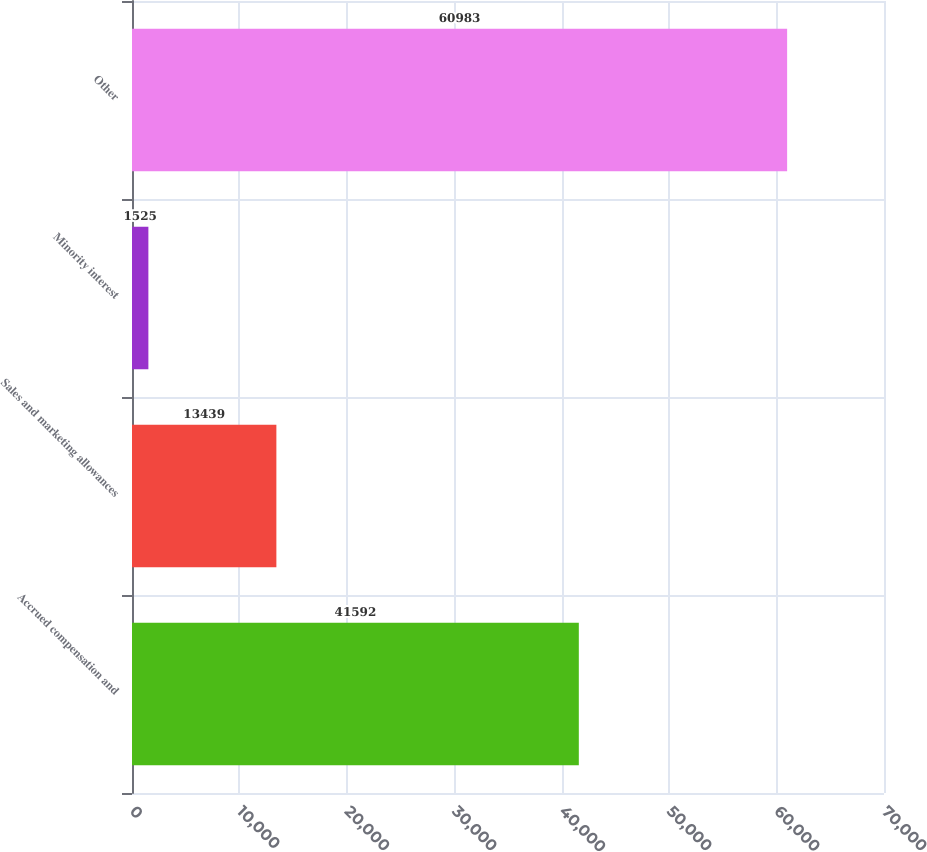Convert chart. <chart><loc_0><loc_0><loc_500><loc_500><bar_chart><fcel>Accrued compensation and<fcel>Sales and marketing allowances<fcel>Minority interest<fcel>Other<nl><fcel>41592<fcel>13439<fcel>1525<fcel>60983<nl></chart> 